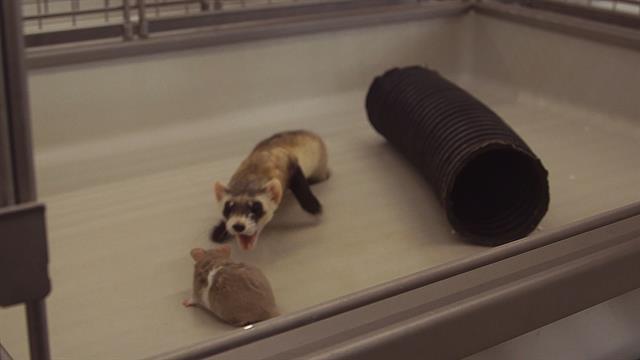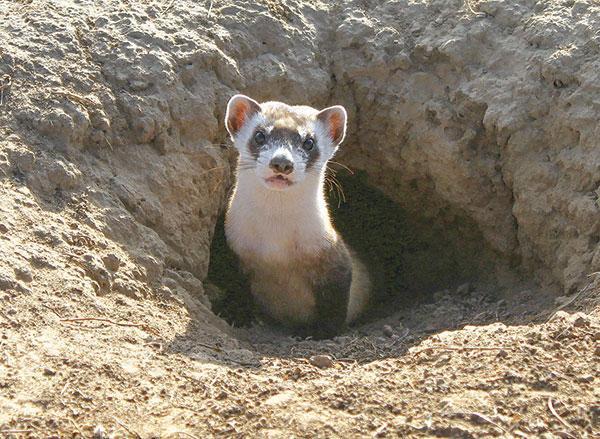The first image is the image on the left, the second image is the image on the right. Assess this claim about the two images: "There are exactly two animals in the image on the left.". Correct or not? Answer yes or no. Yes. 